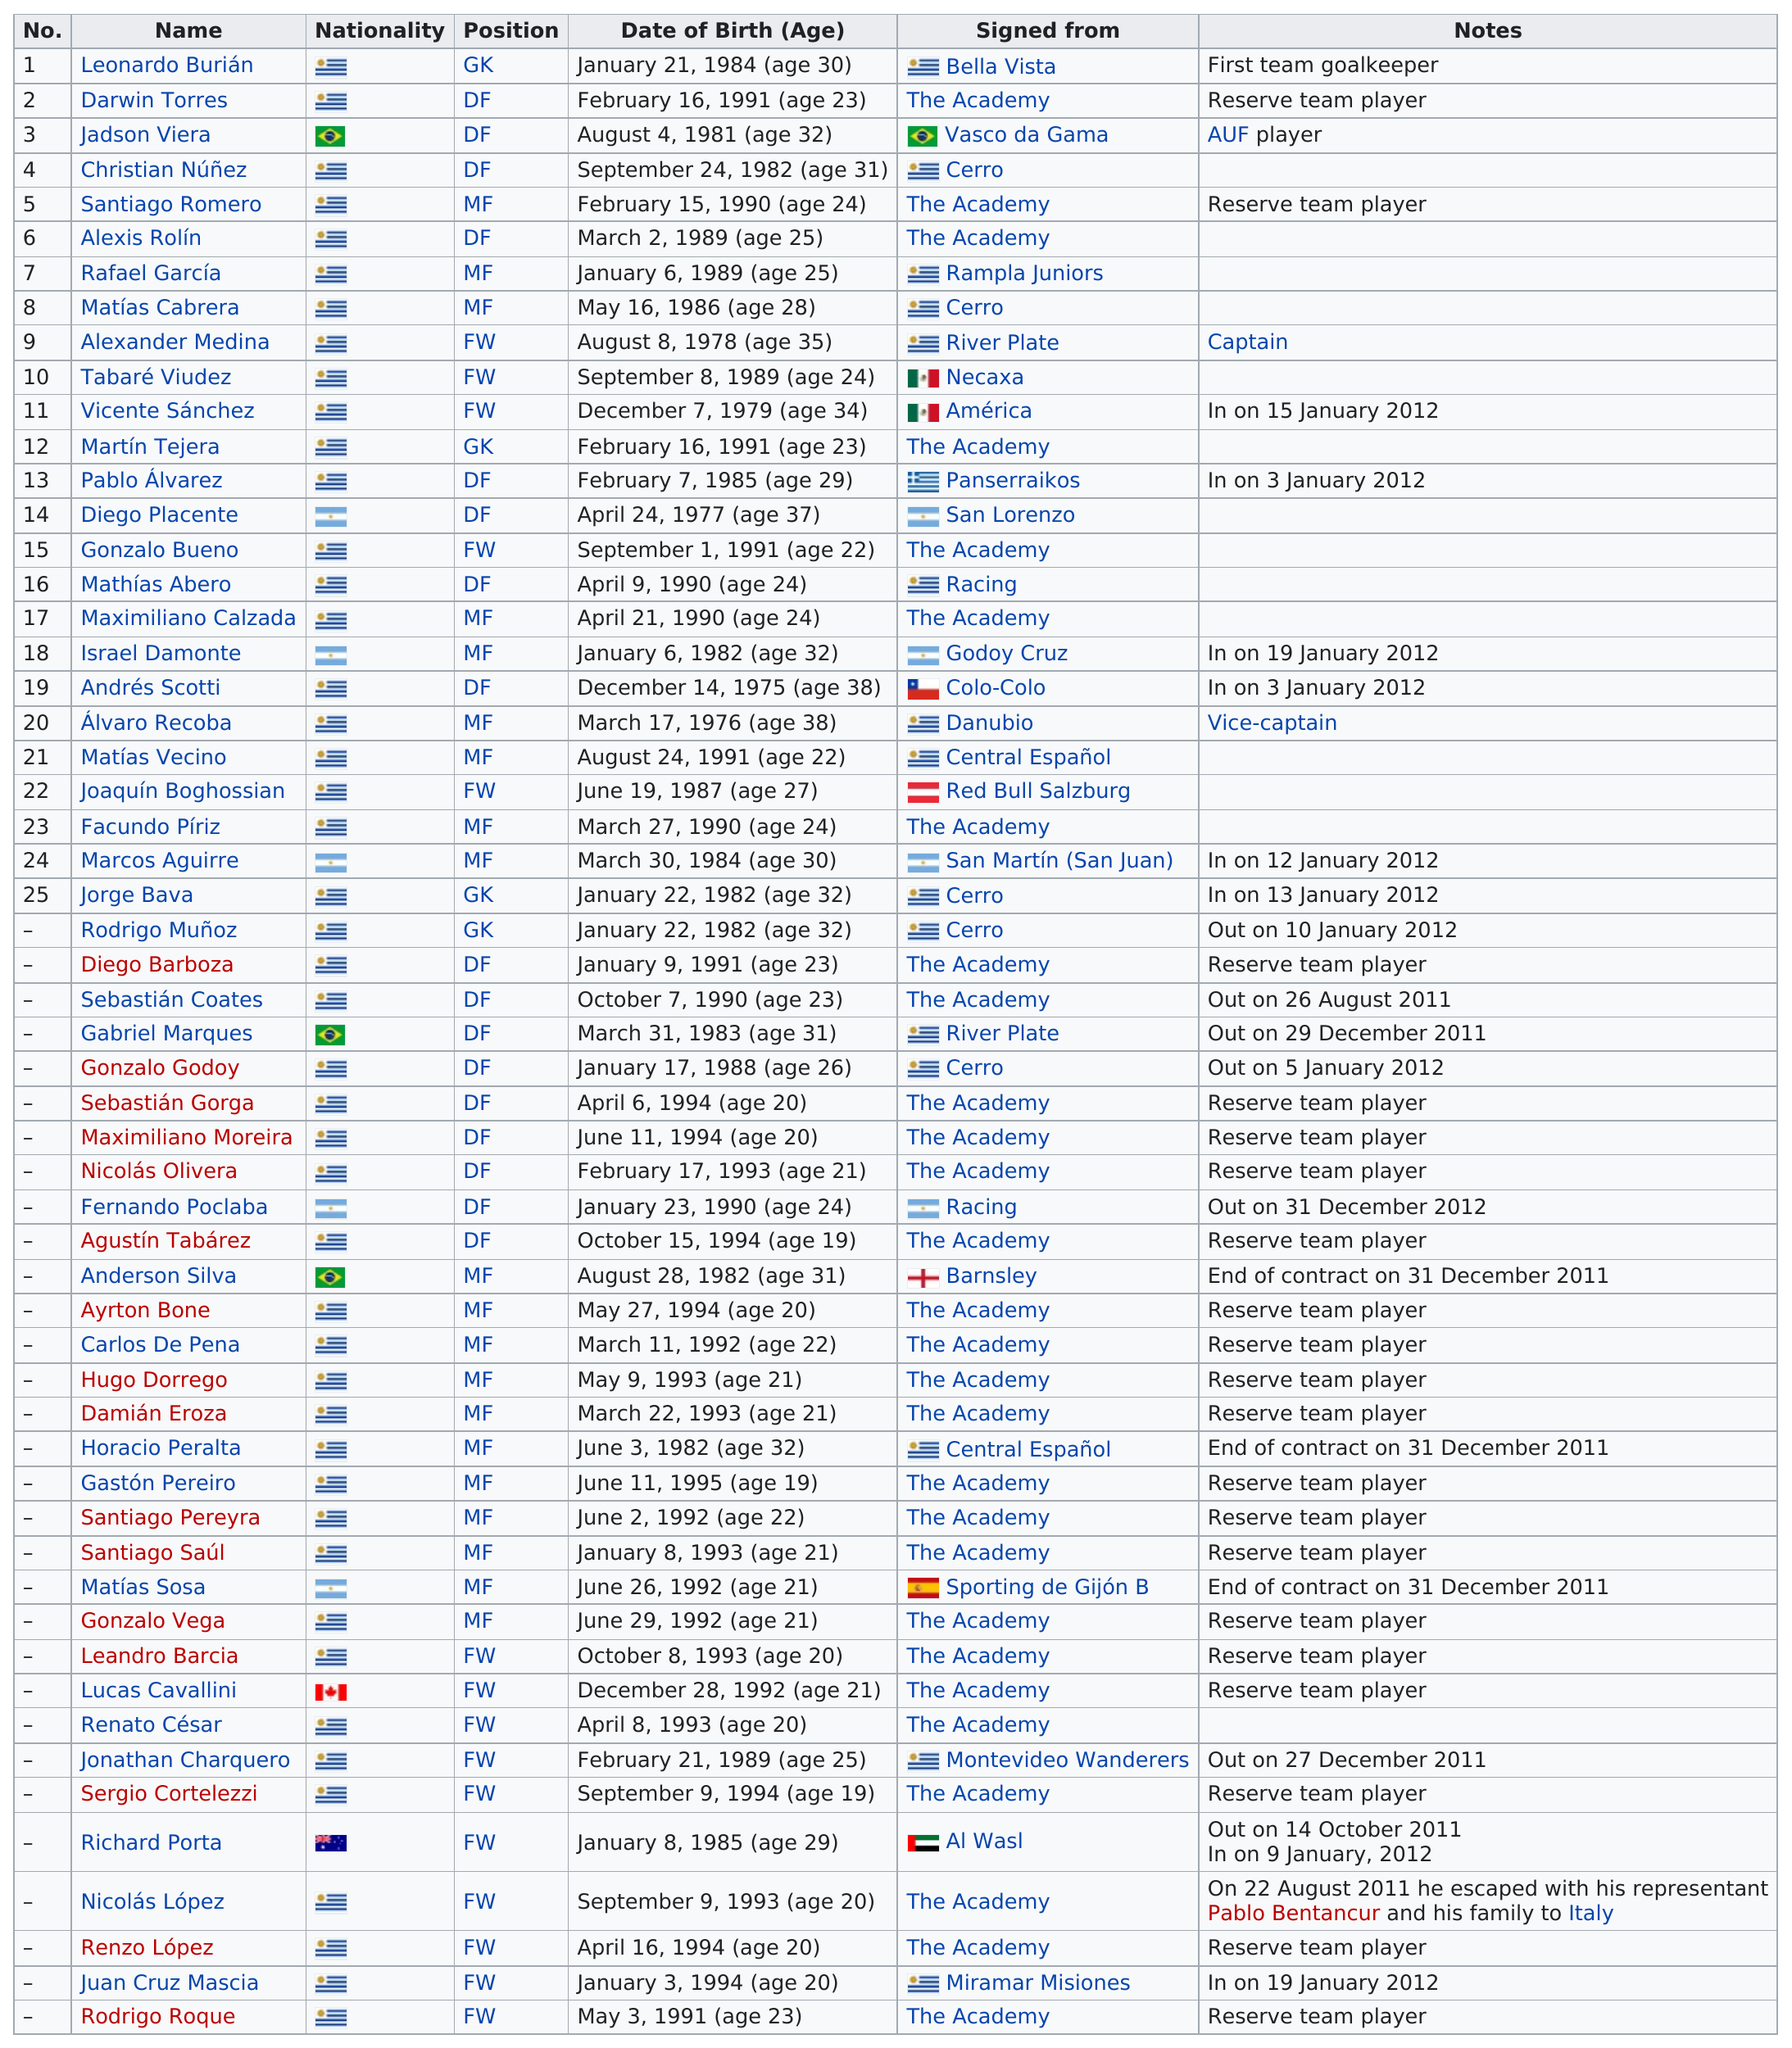Indicate a few pertinent items in this graphic. In the 2011-2012 season, the total number of Canadian players on the team roster was one. Out of the total number of players, 1 player is Australian. There are 19 reserve team players. In total, 28 players were not signed from the academy. Tabaré Viudez, a player from Uruguay, was signed from Mexico. 